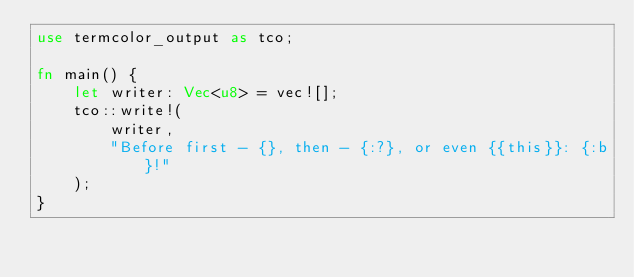Convert code to text. <code><loc_0><loc_0><loc_500><loc_500><_Rust_>use termcolor_output as tco;

fn main() {
    let writer: Vec<u8> = vec![];
    tco::write!(
        writer,
        "Before first - {}, then - {:?}, or even {{this}}: {:b}!"
    );
}
</code> 